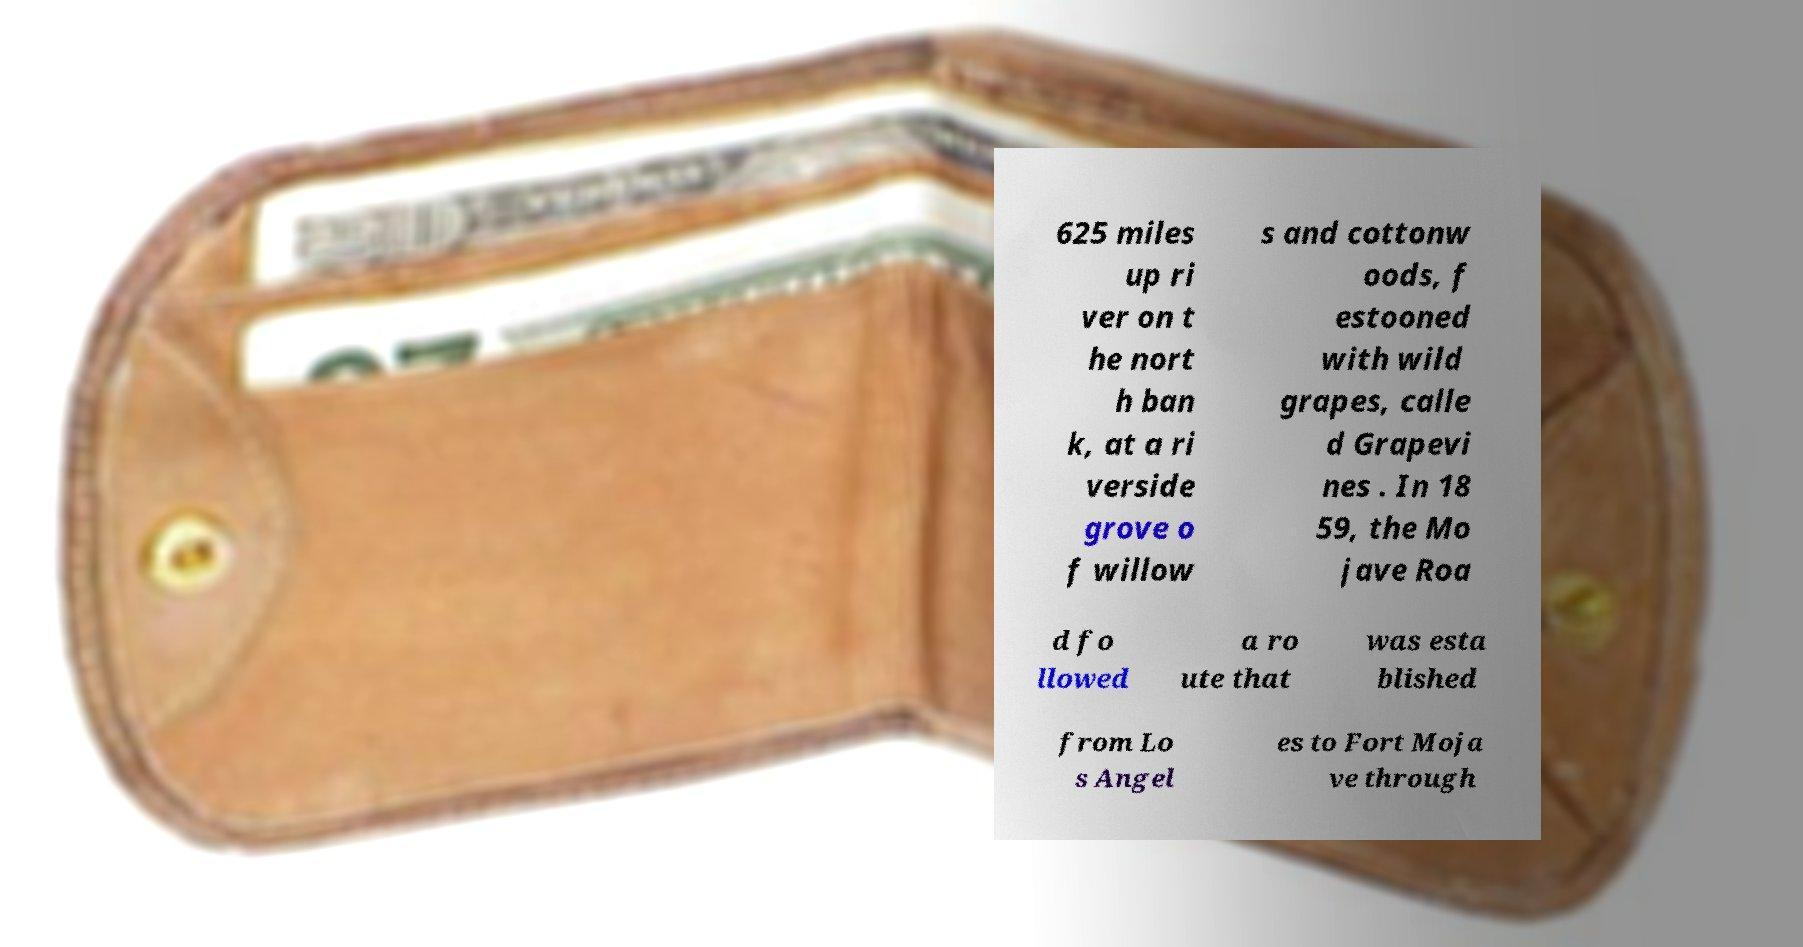Could you assist in decoding the text presented in this image and type it out clearly? 625 miles up ri ver on t he nort h ban k, at a ri verside grove o f willow s and cottonw oods, f estooned with wild grapes, calle d Grapevi nes . In 18 59, the Mo jave Roa d fo llowed a ro ute that was esta blished from Lo s Angel es to Fort Moja ve through 